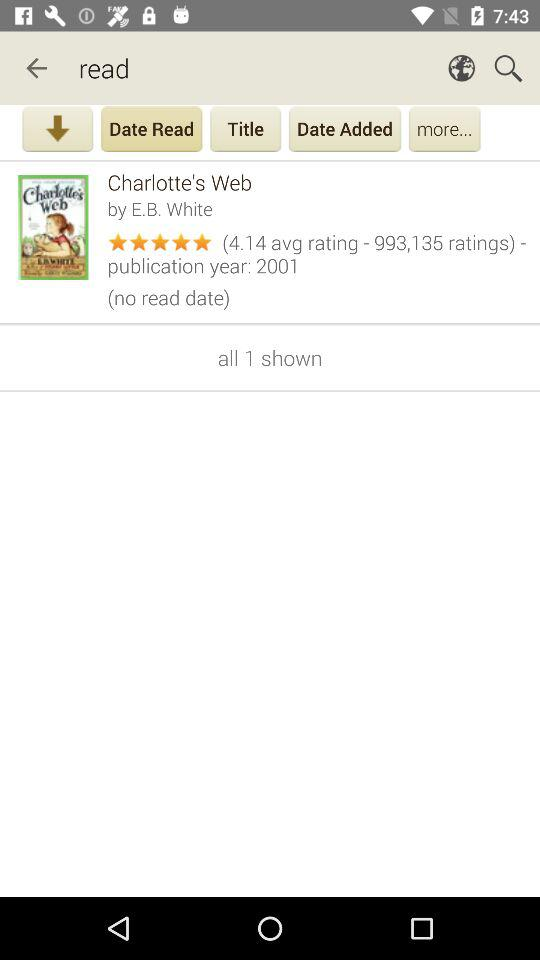How many items are shown on the screen? There is 1 item shown on the screen. 